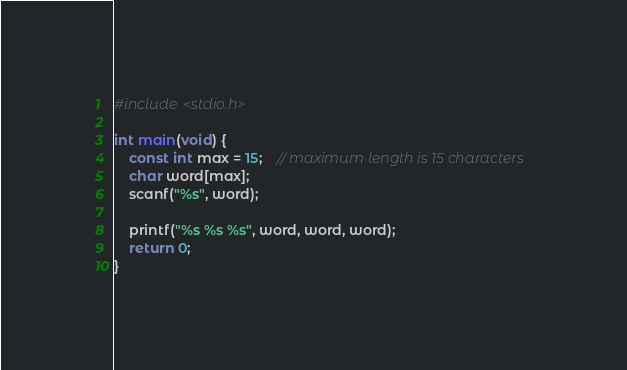<code> <loc_0><loc_0><loc_500><loc_500><_C_>#include <stdio.h>

int main(void) {
    const int max = 15;    // maximum length is 15 characters
    char word[max];
    scanf("%s", word);

    printf("%s %s %s", word, word, word);
    return 0;
}
</code> 